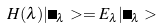Convert formula to latex. <formula><loc_0><loc_0><loc_500><loc_500>H ( \lambda ) | \Psi _ { \lambda } > = E _ { \lambda } | \Psi _ { \lambda } ></formula> 